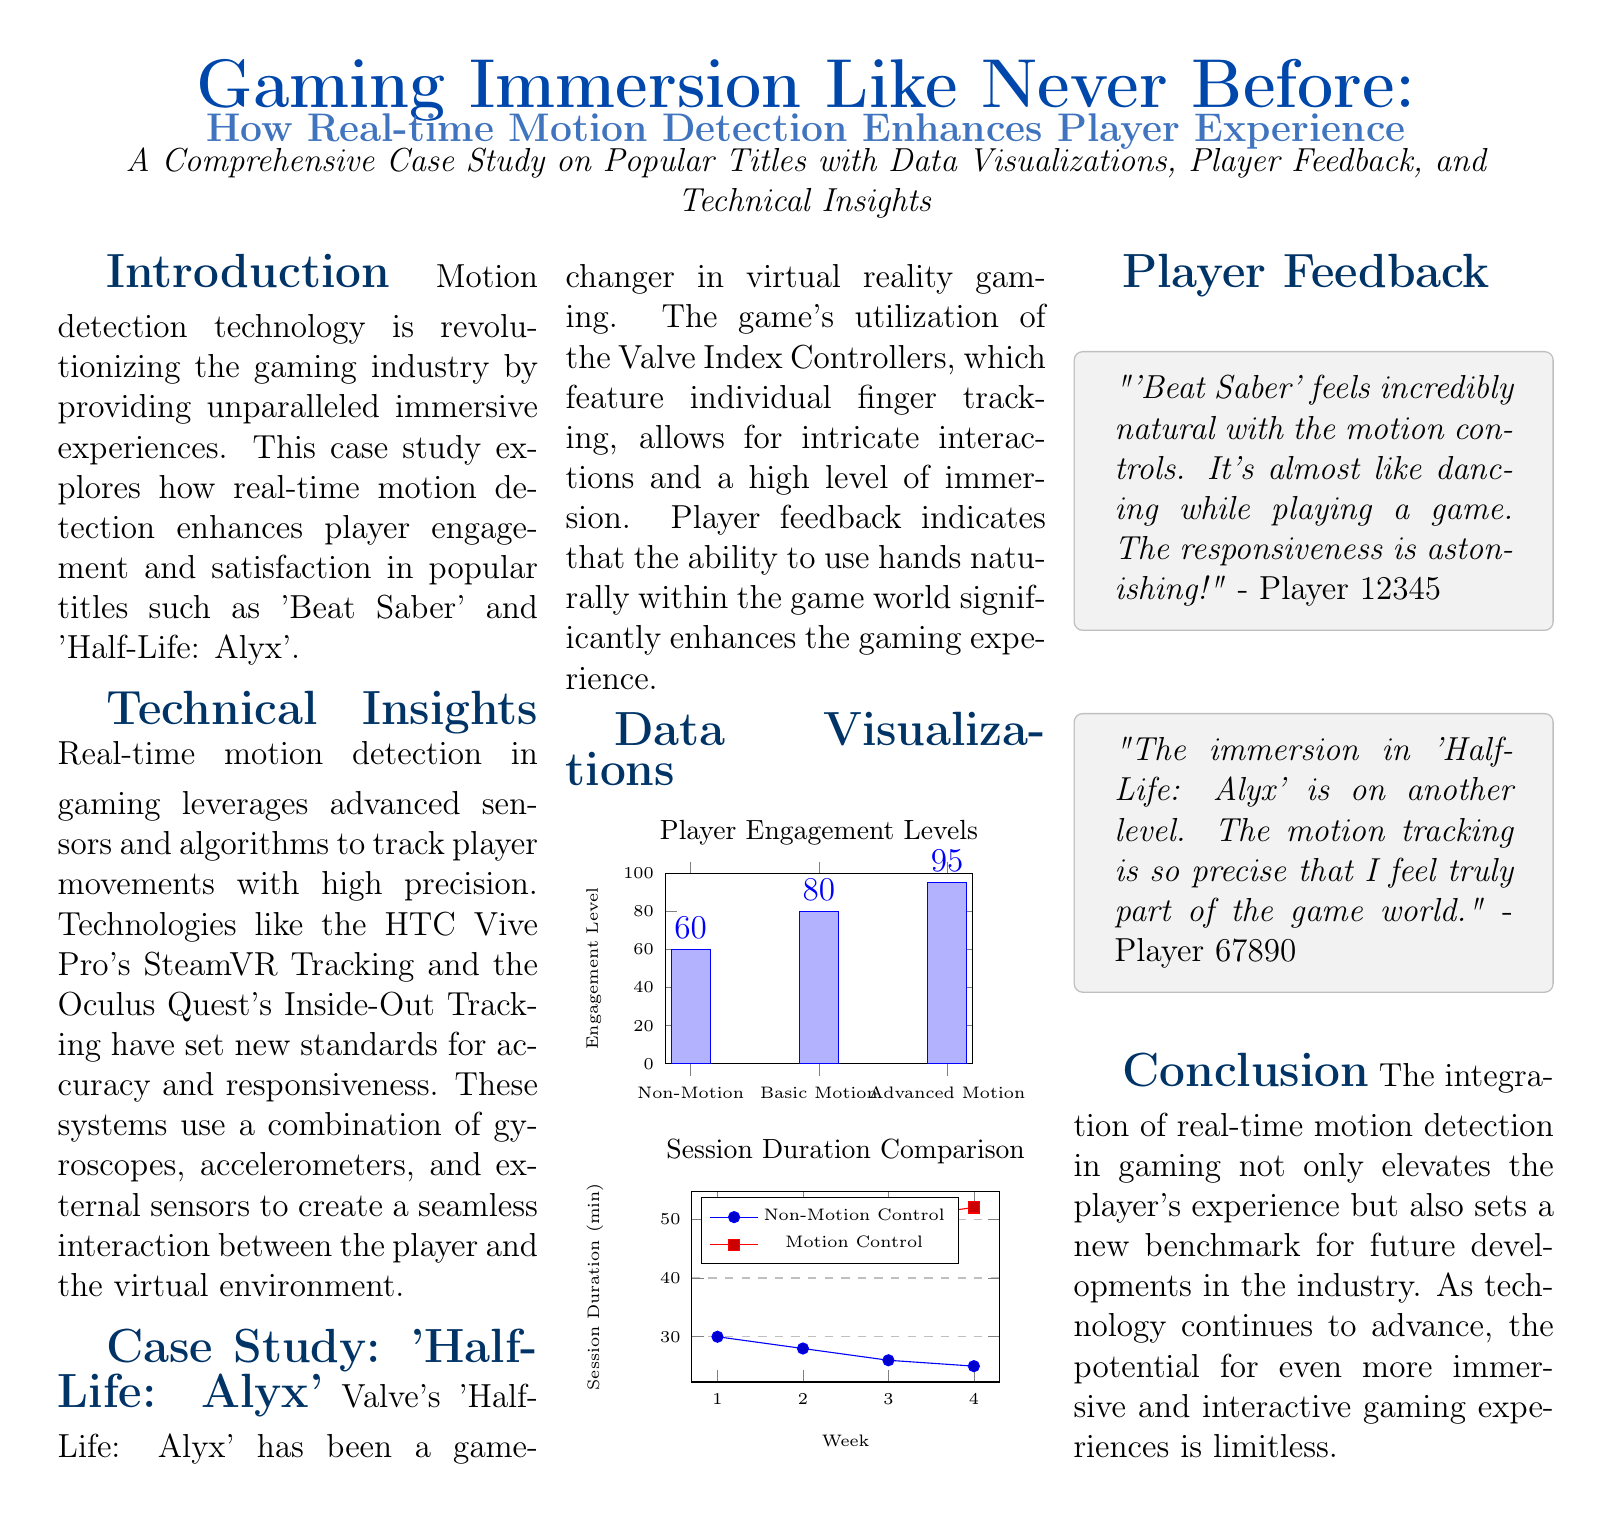What technologies are highlighted for motion detection? The document mentions HTC Vive Pro's SteamVR Tracking and Oculus Quest's Inside-Out Tracking as technologies utilized for motion detection in gaming.
Answer: HTC Vive Pro, Oculus Quest What is the engagement level for Advanced Motion? The engagement level for Advanced Motion is provided in the data visualizations section of the document.
Answer: 95 Which game features individual finger tracking? The document states that 'Half-Life: Alyx' utilizes individual finger tracking through the Valve Index Controllers.
Answer: Half-Life: Alyx What was the session duration for Motion Control in Week 4? The comparison chart shows the session duration for Motion Control in the fourth week.
Answer: 52 What percentage increase was observed from Non-Motion to Advanced Motion engagement? This requires calculating the difference between Non-Motion and Advanced Motion engagement levels as shown in the data visualizations.
Answer: 35 Which player believed that 'Beat Saber' felt incredibly natural? The player feedback section quotes a player's experience, offering insight into their feelings towards 'Beat Saber'.
Answer: Player 12345 What does the conclusion state about future developments in the industry? The conclusion summarizes the potential for immersive and interactive gaming experiences as technology advances.
Answer: Limitless What color is used for the section titles in the document? The section titles are formatted in a specific color, which is described in the document.
Answer: Section color What does the title of the document highlight about gaming immersion? The title emphasizes the revolutionary aspect of gaming immersion through technology.
Answer: Like Never Before 